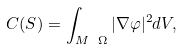<formula> <loc_0><loc_0><loc_500><loc_500>C ( S ) = \int _ { M \ \Omega } | \nabla \varphi | ^ { 2 } d V ,</formula> 